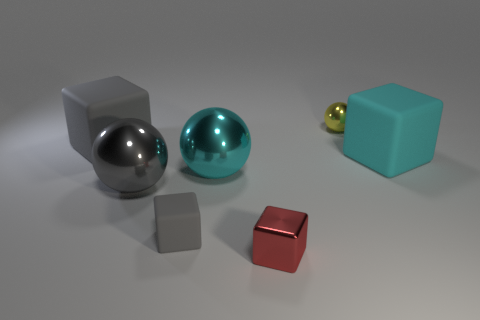There is a cyan thing left of the tiny red metal block; does it have the same size as the cube on the right side of the yellow metal object? The cyan object, which appears to be a sphere, is indeed similar in size to the cube on the right side of the smaller yellow sphere, although without specific measurements, it is difficult to ascertain if they are exactly identical in size. 